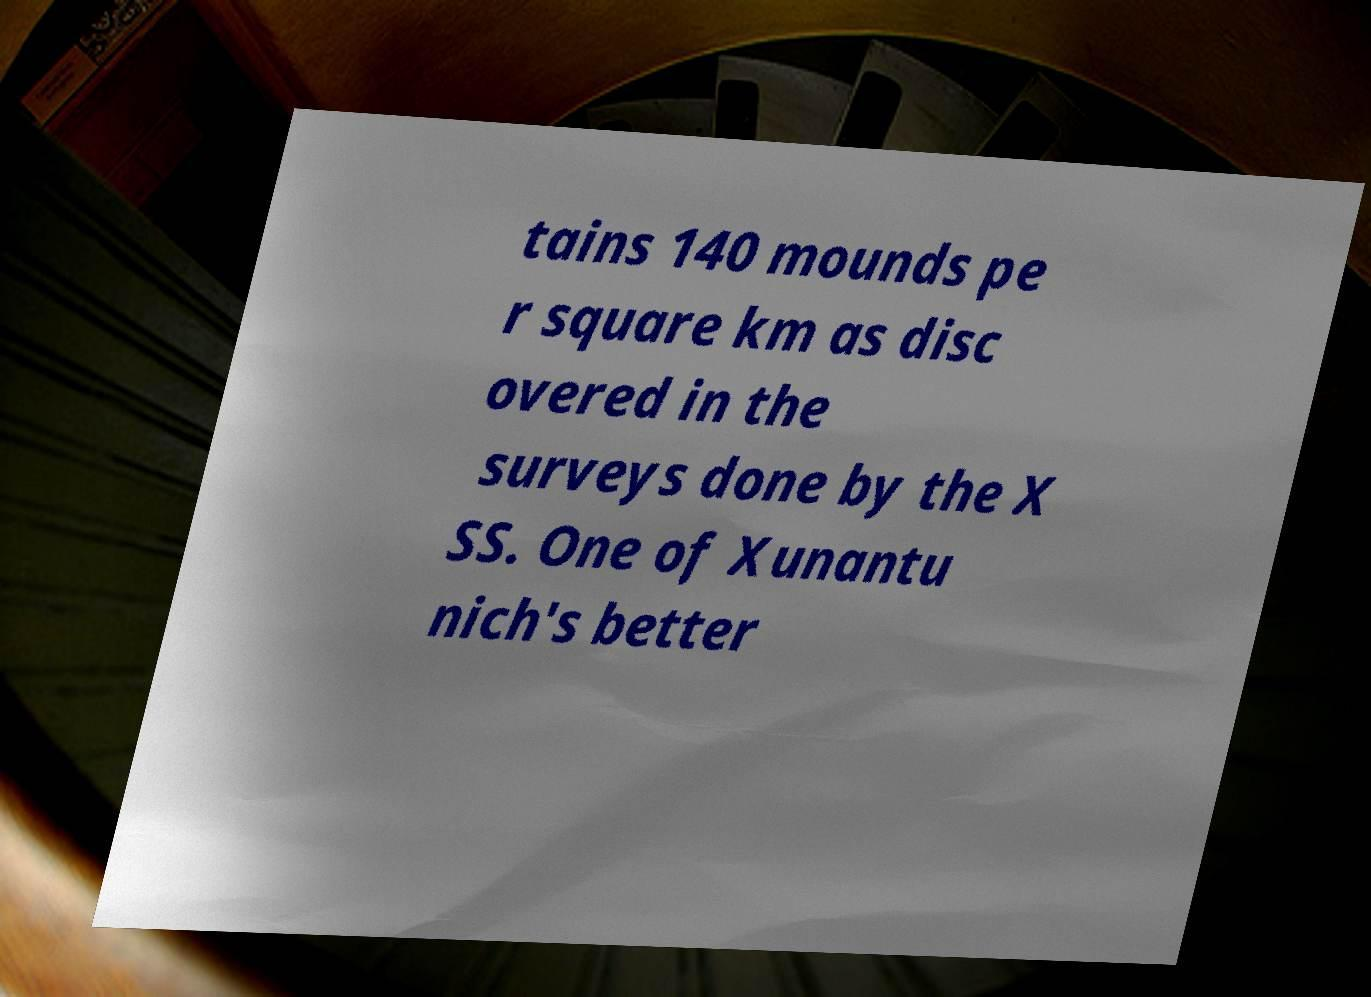For documentation purposes, I need the text within this image transcribed. Could you provide that? tains 140 mounds pe r square km as disc overed in the surveys done by the X SS. One of Xunantu nich's better 